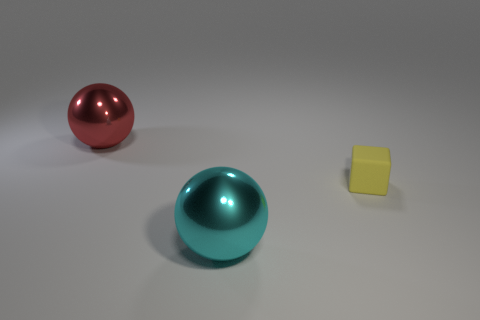What number of other objects are there of the same shape as the big red metallic thing?
Your answer should be very brief. 1. What is the shape of the rubber thing?
Give a very brief answer. Cube. Is the small object made of the same material as the big red object?
Your answer should be compact. No. Is the number of cyan metallic things behind the small matte object the same as the number of small yellow cubes in front of the big cyan metallic ball?
Offer a terse response. Yes. There is a metal object that is right of the shiny ball that is behind the small yellow rubber object; are there any matte blocks on the right side of it?
Provide a short and direct response. Yes. Does the block have the same size as the cyan shiny sphere?
Ensure brevity in your answer.  No. There is a large sphere in front of the big metallic ball that is behind the cyan shiny sphere that is left of the tiny yellow rubber object; what is its color?
Offer a terse response. Cyan. What number of large metal balls have the same color as the matte thing?
Keep it short and to the point. 0. How many tiny objects are either spheres or green rubber balls?
Your answer should be very brief. 0. Is there a big cyan thing that has the same shape as the yellow rubber thing?
Your response must be concise. No. 